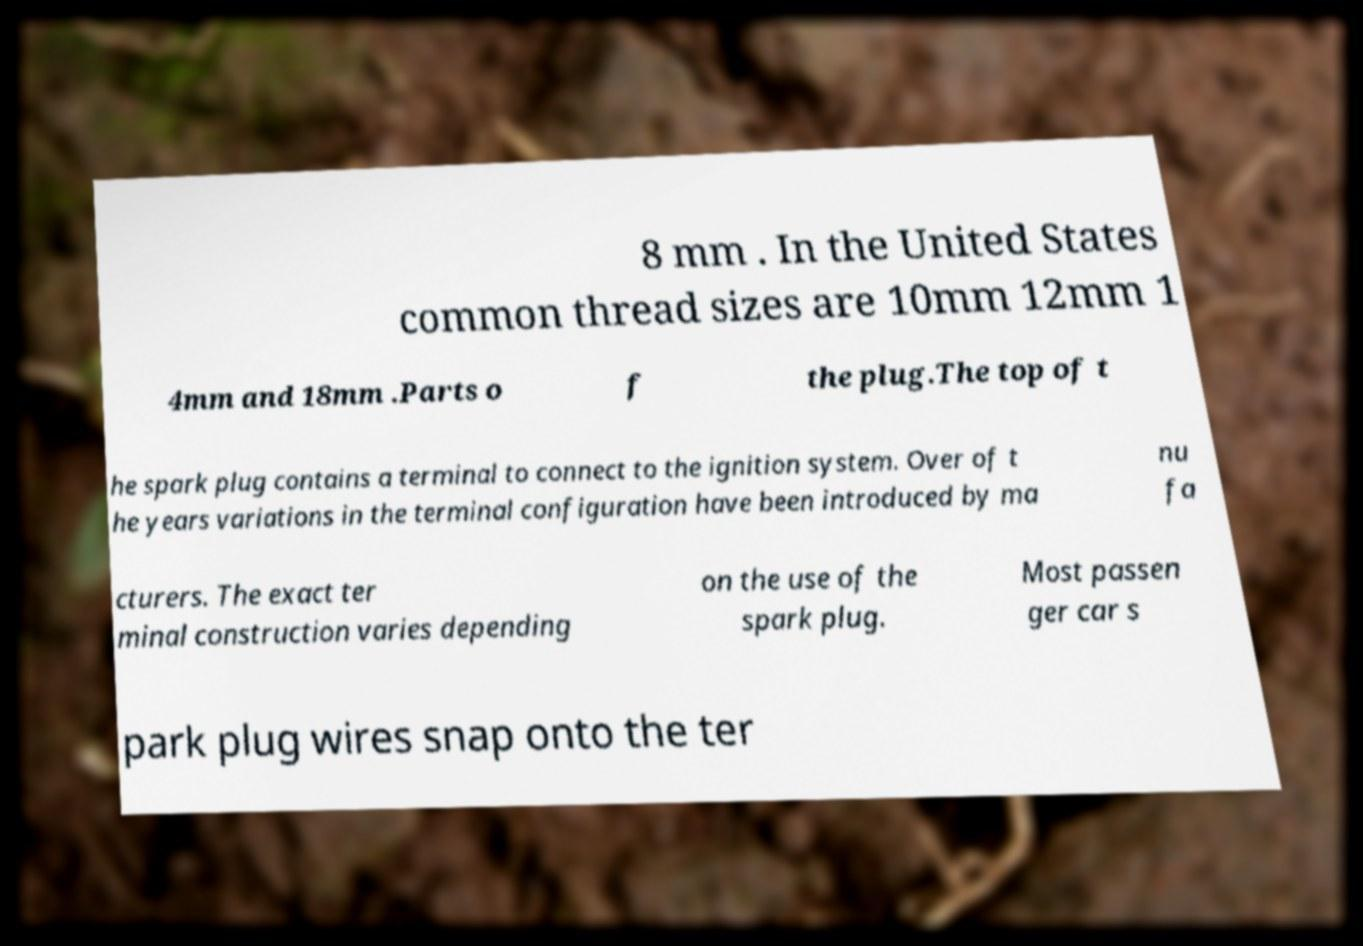Can you read and provide the text displayed in the image?This photo seems to have some interesting text. Can you extract and type it out for me? 8 mm . In the United States common thread sizes are 10mm 12mm 1 4mm and 18mm .Parts o f the plug.The top of t he spark plug contains a terminal to connect to the ignition system. Over of t he years variations in the terminal configuration have been introduced by ma nu fa cturers. The exact ter minal construction varies depending on the use of the spark plug. Most passen ger car s park plug wires snap onto the ter 